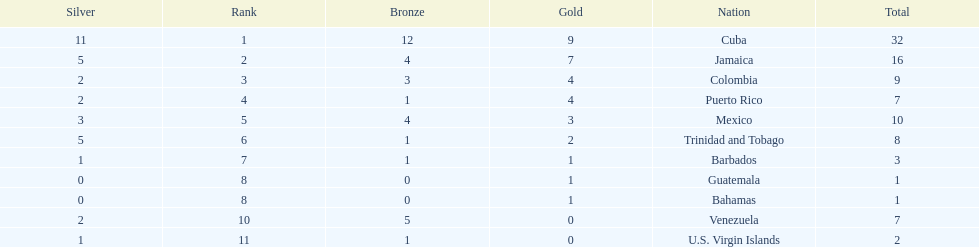Number of teams above 9 medals 3. 